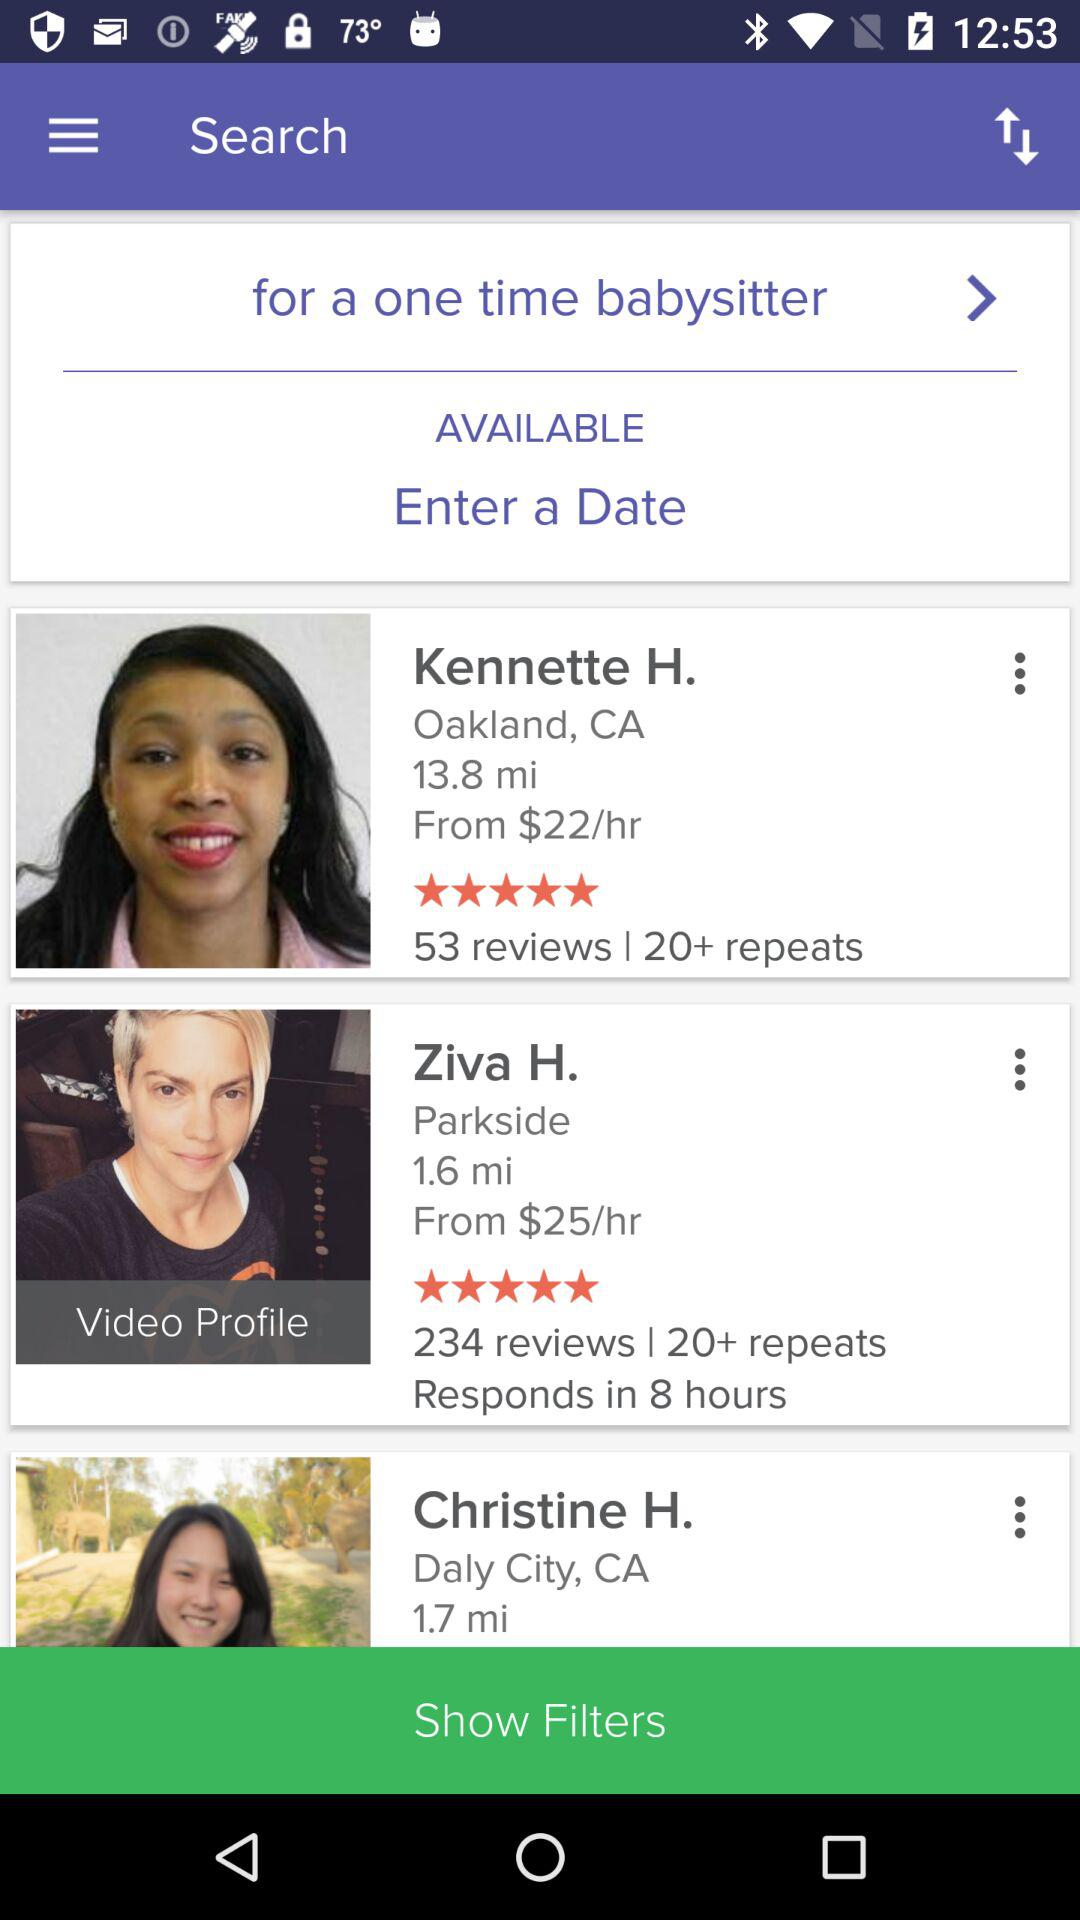How many reviews does Ziva H. have?
Answer the question using a single word or phrase. 234 